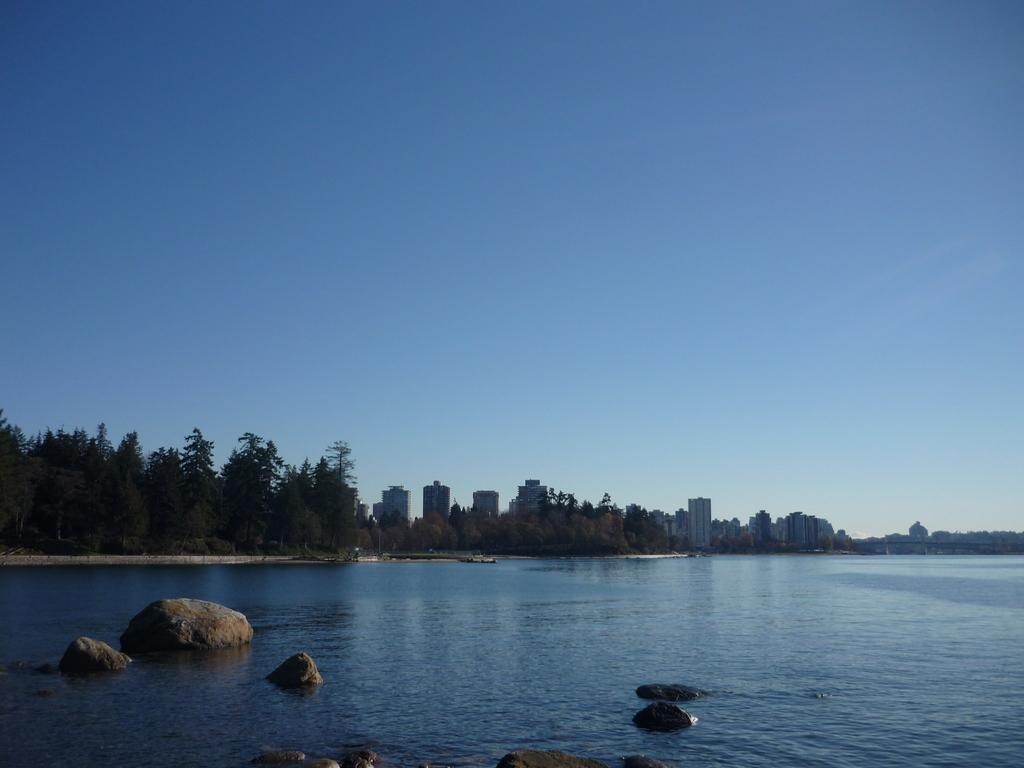What is in the water in the image? There are rocks in the water in the image. What type of vegetation can be seen in the image? There are trees visible in the image. What type of structures can be seen in the image? There are buildings visible in the image. What part of the natural environment is visible in the image? The sky is visible in the image. What type of table is visible in the image? There is no table present in the image. What kind of experience can be gained from the rocks in the water? The image does not convey any experience related to the rocks in the water; it simply shows their presence. 